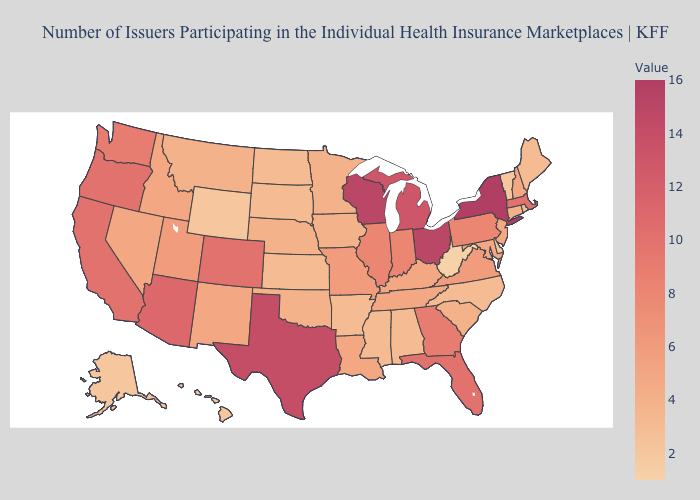Among the states that border Rhode Island , does Connecticut have the lowest value?
Concise answer only. Yes. Among the states that border Michigan , does Ohio have the lowest value?
Keep it brief. No. Which states hav the highest value in the West?
Answer briefly. Arizona. Does the map have missing data?
Be succinct. No. 